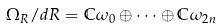<formula> <loc_0><loc_0><loc_500><loc_500>\Omega _ { R } / d R = \mathbb { C } \omega _ { 0 } \oplus \dots \oplus \mathbb { C } \omega _ { 2 n }</formula> 